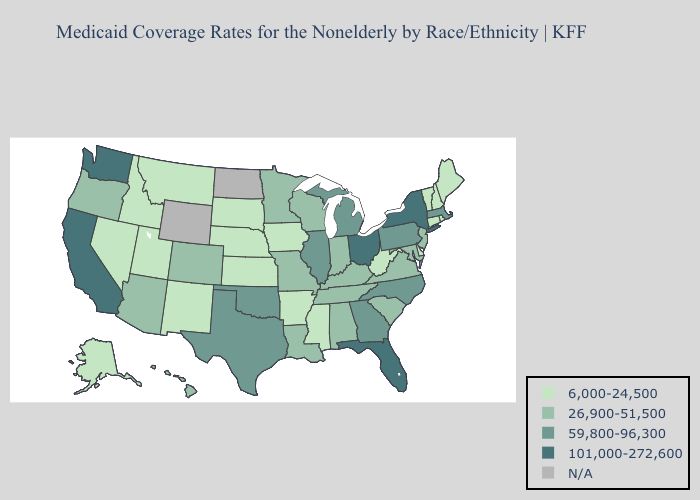Name the states that have a value in the range 101,000-272,600?
Answer briefly. California, Florida, New York, Ohio, Washington. What is the highest value in the Northeast ?
Be succinct. 101,000-272,600. What is the highest value in the Northeast ?
Write a very short answer. 101,000-272,600. What is the highest value in the West ?
Be succinct. 101,000-272,600. What is the value of Maine?
Write a very short answer. 6,000-24,500. What is the value of North Carolina?
Give a very brief answer. 59,800-96,300. Does Massachusetts have the highest value in the Northeast?
Give a very brief answer. No. What is the lowest value in states that border Nevada?
Short answer required. 6,000-24,500. Which states have the highest value in the USA?
Answer briefly. California, Florida, New York, Ohio, Washington. What is the highest value in states that border Tennessee?
Answer briefly. 59,800-96,300. Name the states that have a value in the range 59,800-96,300?
Concise answer only. Georgia, Illinois, Massachusetts, Michigan, North Carolina, Oklahoma, Pennsylvania, Texas. What is the value of New Hampshire?
Short answer required. 6,000-24,500. Name the states that have a value in the range N/A?
Keep it brief. North Dakota, Wyoming. Name the states that have a value in the range 26,900-51,500?
Write a very short answer. Alabama, Arizona, Colorado, Hawaii, Indiana, Kentucky, Louisiana, Maryland, Minnesota, Missouri, New Jersey, Oregon, South Carolina, Tennessee, Virginia, Wisconsin. 